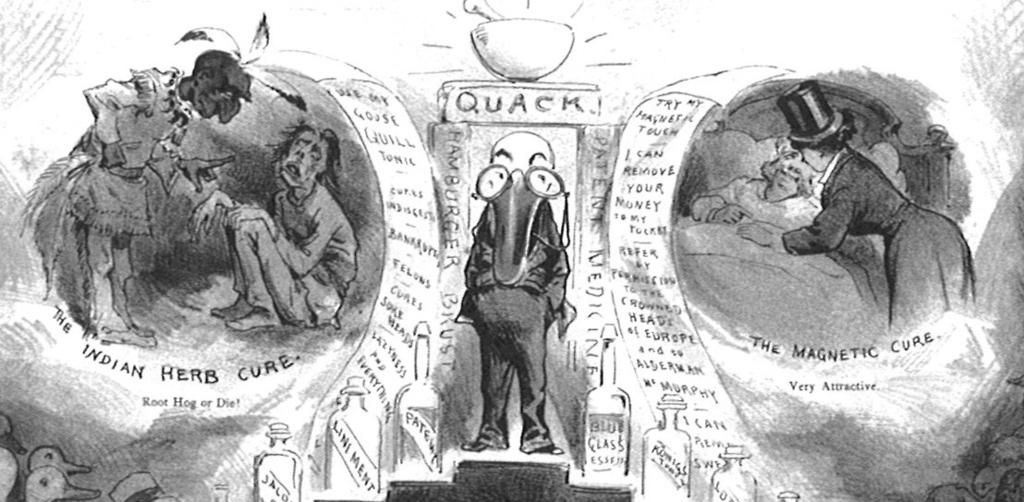What is present in the image that features a design or message? There is a poster in the image. Can you describe the color scheme of the poster? The poster has both black and white elements and color elements. What type of images are on the poster? There are cartoon images on the poster. Is there any text on the poster? Yes, there is text on the poster. How many lizards are crawling on the poster in the image? There are no lizards present on the poster in the image. Is there a curve on the poster that indicates a trip or journey? There is no curve or indication of a trip or journey on the poster in the image. 